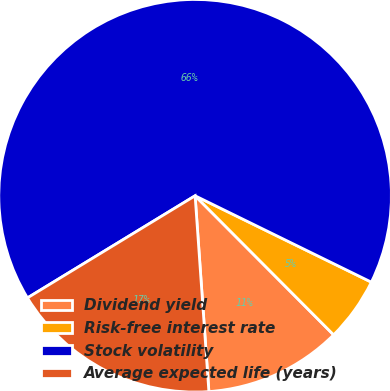Convert chart to OTSL. <chart><loc_0><loc_0><loc_500><loc_500><pie_chart><fcel>Dividend yield<fcel>Risk-free interest rate<fcel>Stock volatility<fcel>Average expected life (years)<nl><fcel>11.35%<fcel>5.28%<fcel>65.96%<fcel>17.41%<nl></chart> 